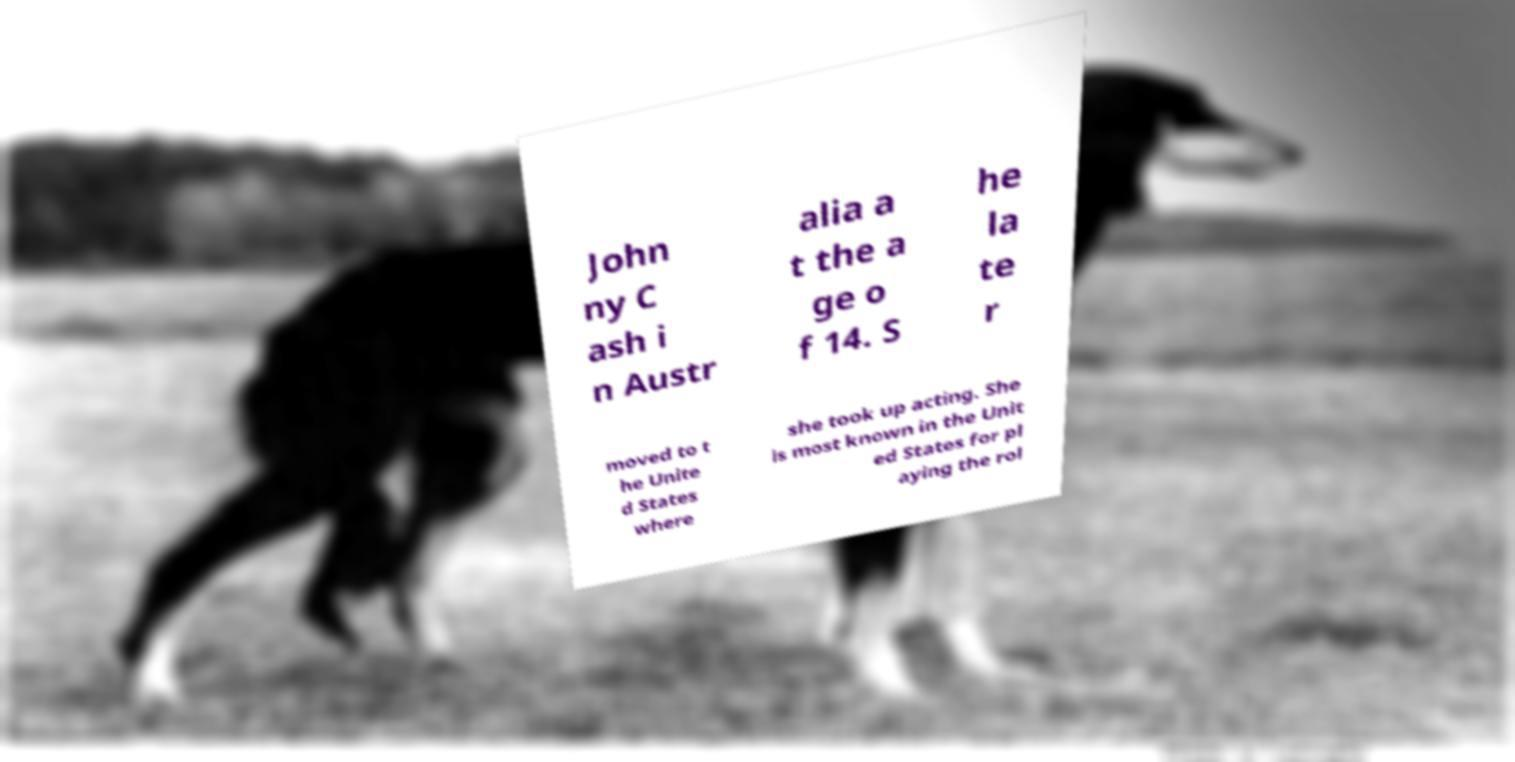Please identify and transcribe the text found in this image. John ny C ash i n Austr alia a t the a ge o f 14. S he la te r moved to t he Unite d States where she took up acting. She is most known in the Unit ed States for pl aying the rol 